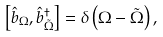<formula> <loc_0><loc_0><loc_500><loc_500>\left [ \hat { b } _ { \Omega } , \hat { b } _ { \tilde { \Omega } } ^ { \dagger } \right ] = \delta \left ( \Omega - \tilde { \Omega } \right ) ,</formula> 